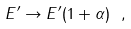Convert formula to latex. <formula><loc_0><loc_0><loc_500><loc_500>E ^ { \prime } \to E ^ { \prime } ( 1 + \alpha ) \ ,</formula> 